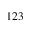<formula> <loc_0><loc_0><loc_500><loc_500>1 2 3</formula> 